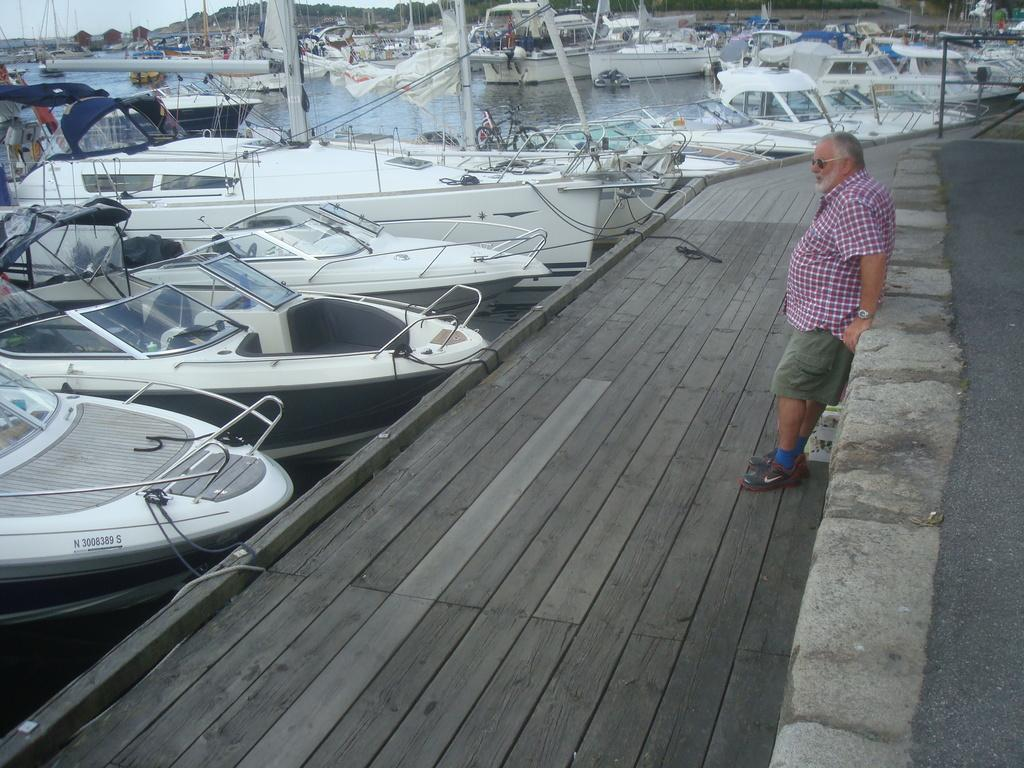What is located on the right side of the image? There is a man standing on the right side of the image. What is the man wearing in the image? The man is wearing a shirt and shorts. What can be seen on the left side of the image? There are boats parked on the left side of the image. What is the color of the boats in the image? The boats are white in color. What is visible in the middle of the image? There is water visible in the middle of the image. Can you tell me how many forks are used to play with the boats in the image? There are no forks present in the image, and the boats are not being played with. 